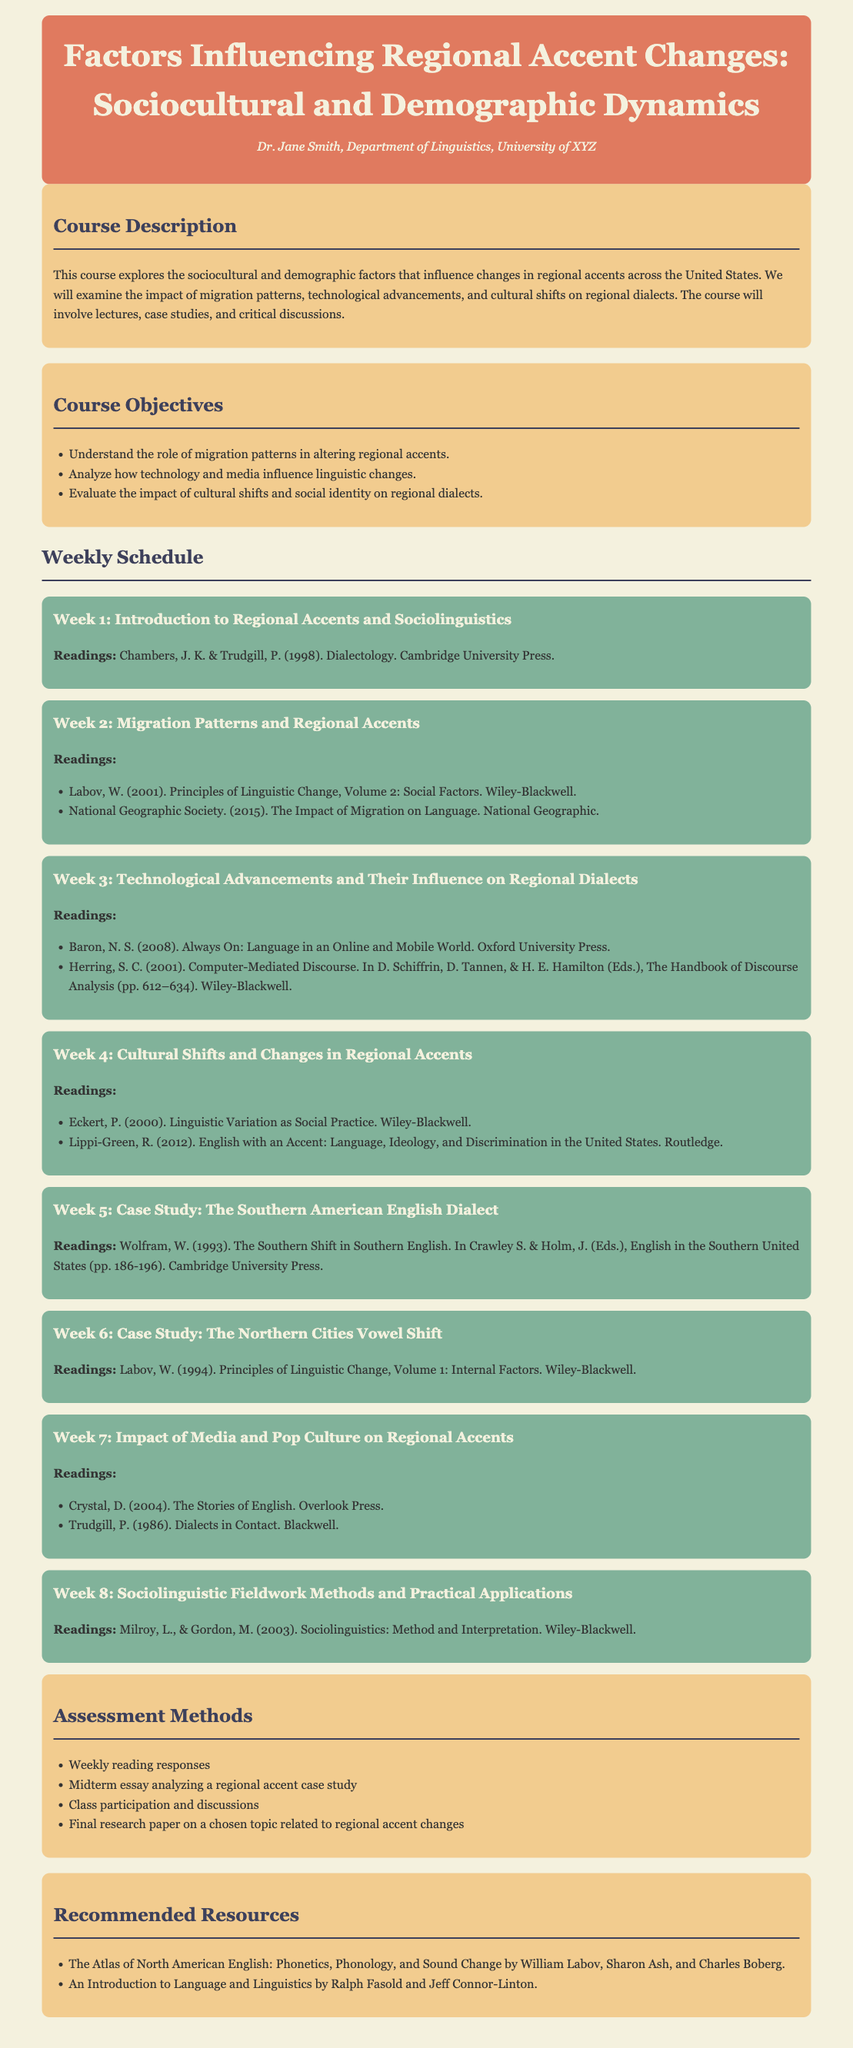What is the title of the course? The title of the course is found in the header of the document.
Answer: Factors Influencing Regional Accent Changes: Sociocultural and Demographic Dynamics Who is the instructor of the course? The instructor's name is mentioned in the header below the course title.
Answer: Dr. Jane Smith What is the primary focus of the course? The primary focus is outlined in the course description section.
Answer: Sociocultural and demographic factors influencing changes in regional accents Which week covers migration patterns? This information is found in the weekly schedule under Week 2.
Answer: Week 2 Name one reading from Week 4. The readings for Week 4 are highlighted in the corresponding week section.
Answer: Eckert, P. (2000). Linguistic Variation as Social Practice What is one method of assessment for the course? Assessment methods are listed in the corresponding section.
Answer: Weekly reading responses How many case studies are included in the course? The weekly schedule mentions two case studies in Weeks 5 and 6.
Answer: Two What is the reading for Week 3? The reading for Week 3 is specified in that week’s details.
Answer: Baron, N. S. (2008). Always On: Language in an Online and Mobile World 